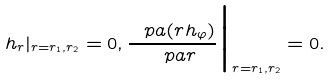<formula> <loc_0><loc_0><loc_500><loc_500>h _ { r } | _ { r = r _ { 1 } , r _ { 2 } } = 0 , \frac { \ p a ( r h _ { \varphi } ) } { \ p a r } \Big | _ { r = r _ { 1 } , r _ { 2 } } = 0 .</formula> 